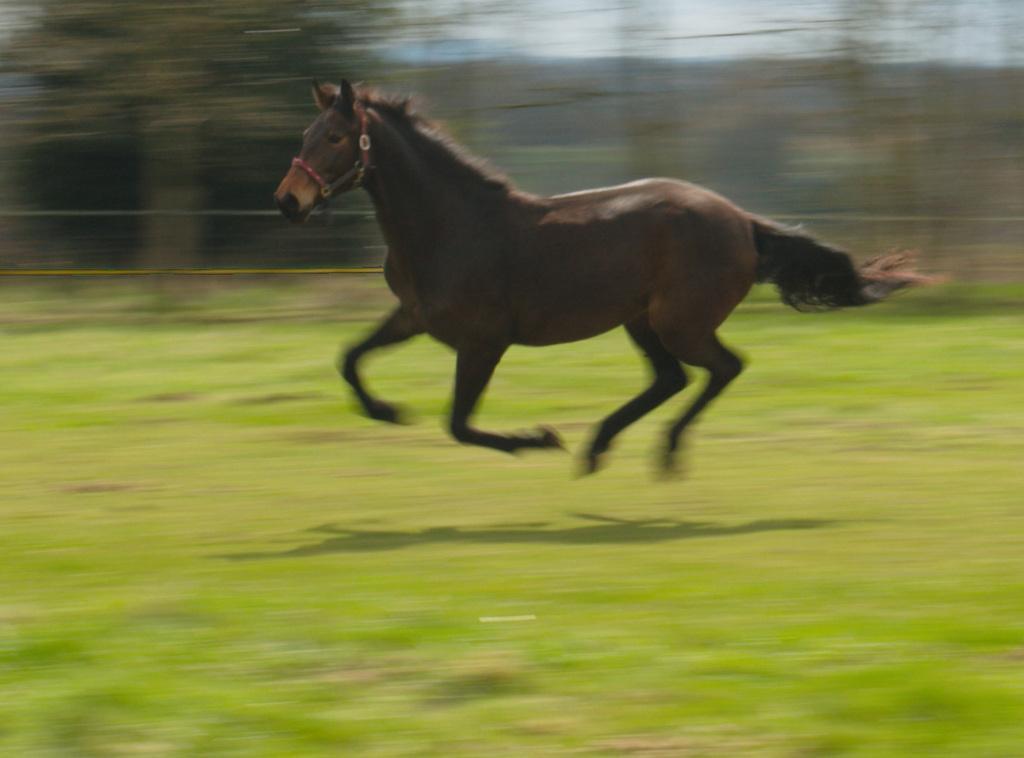Please provide a concise description of this image. In this image there is the sky towards the top of the image, there are trees, there is a fence, there is grass towards the bottom of the image, there is a horse running, the background of the image is blurred. 